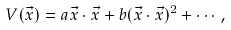Convert formula to latex. <formula><loc_0><loc_0><loc_500><loc_500>V ( \vec { x } ) = a \vec { x } \cdot \vec { x } + b ( \vec { x } \cdot \vec { x } ) ^ { 2 } + \cdots \, ,</formula> 